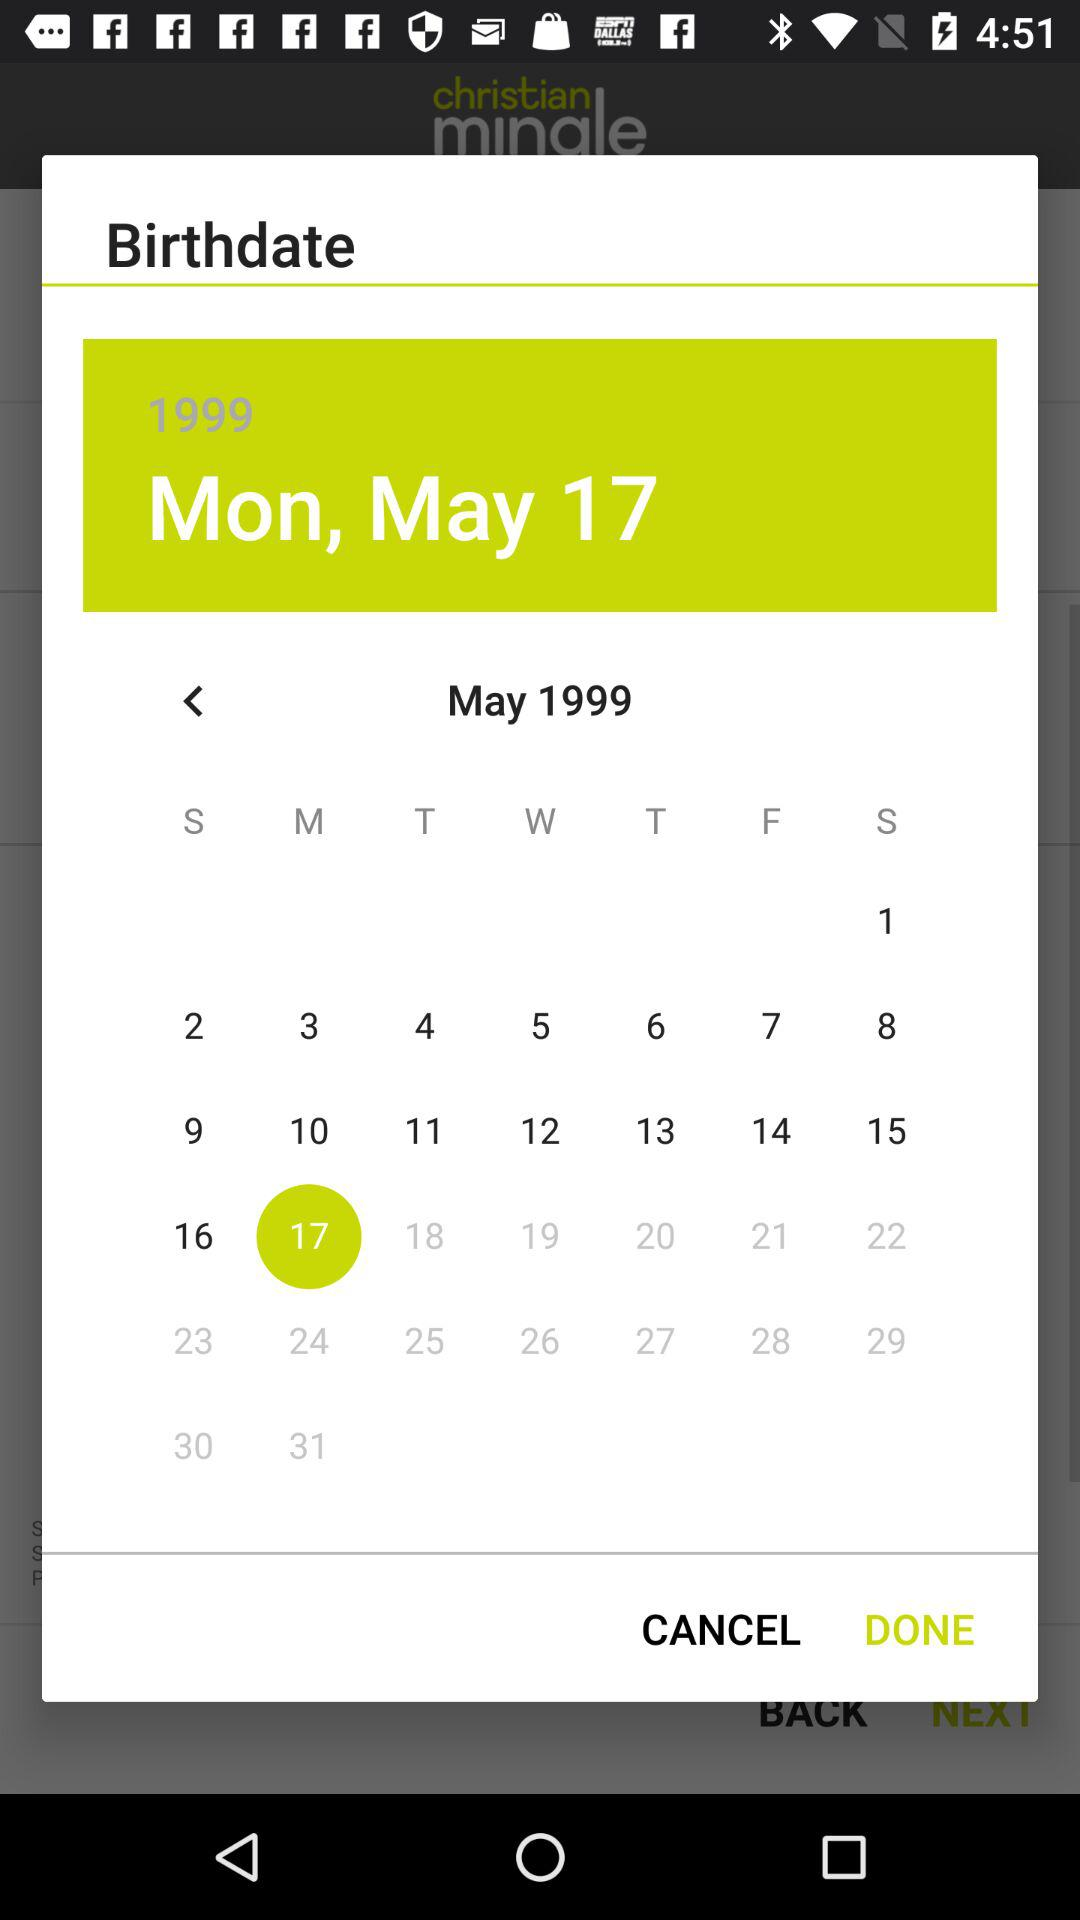Which is the selected date in the calendar? The selected date in the calendar is Monday, May 17, 1999. 